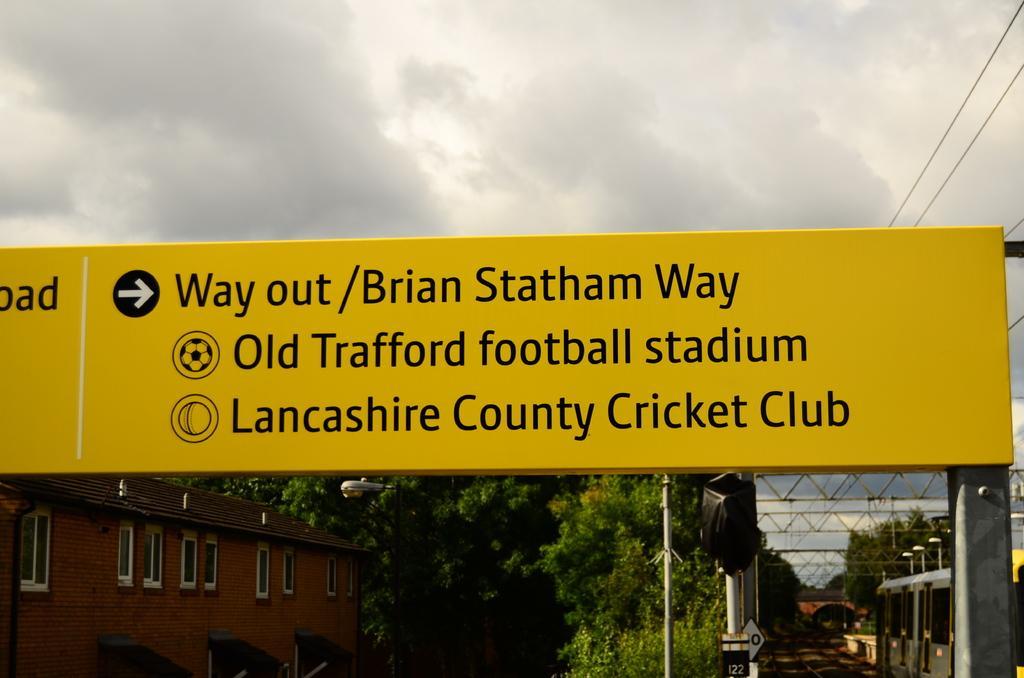Could you give a brief overview of what you see in this image? In this image we can see a yellow color board with some text, there are few buildings, trees, poles, lights and sign boards, in the background we can see the sky. 